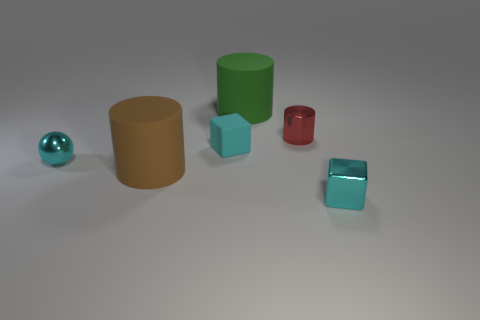How many objects are smaller than the green cylinder? There are three objects smaller than the green cylinder: one small red cylinder and two cyan blocks. 